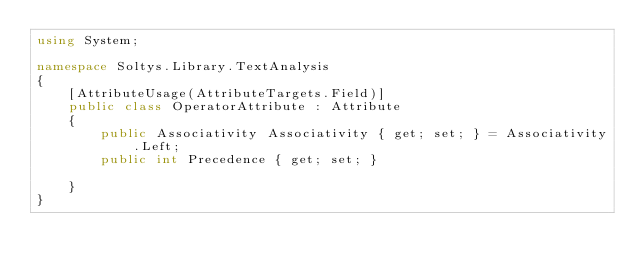<code> <loc_0><loc_0><loc_500><loc_500><_C#_>using System;

namespace Soltys.Library.TextAnalysis
{
    [AttributeUsage(AttributeTargets.Field)]
    public class OperatorAttribute : Attribute
    {
        public Associativity Associativity { get; set; } = Associativity.Left;
        public int Precedence { get; set; }

    }
}
</code> 